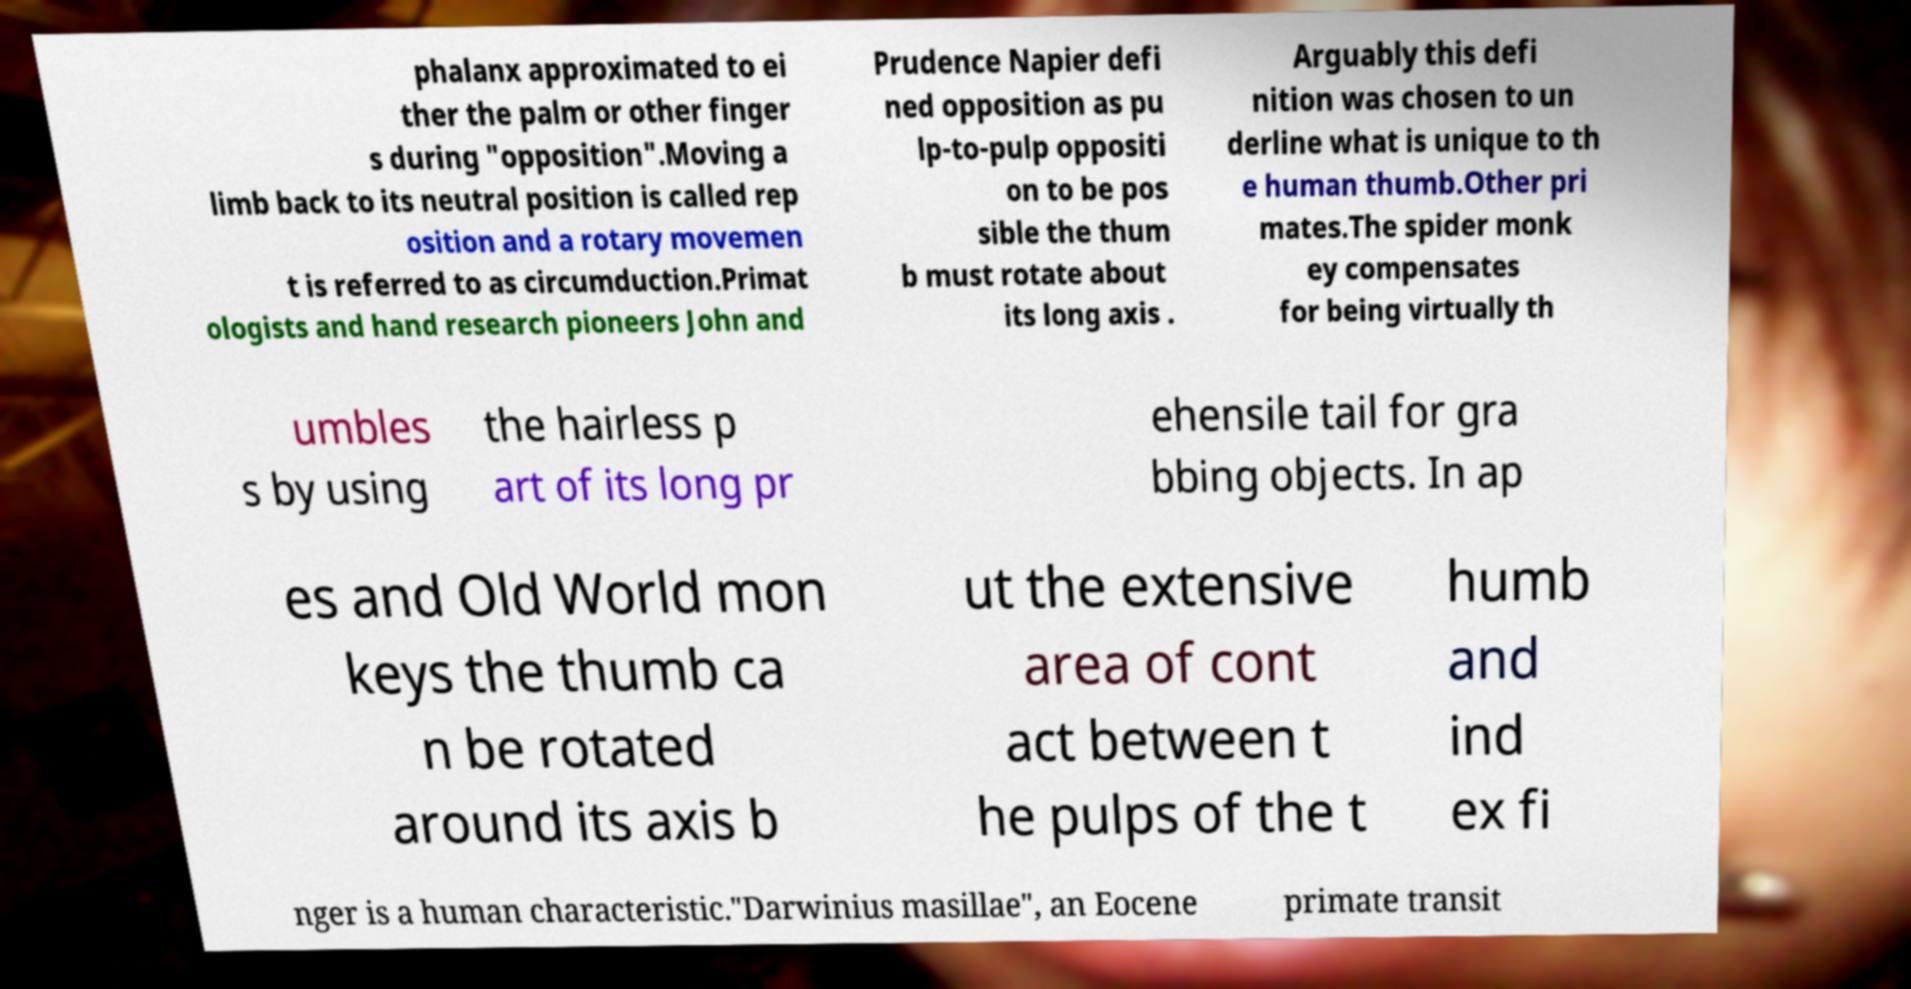Please identify and transcribe the text found in this image. phalanx approximated to ei ther the palm or other finger s during "opposition".Moving a limb back to its neutral position is called rep osition and a rotary movemen t is referred to as circumduction.Primat ologists and hand research pioneers John and Prudence Napier defi ned opposition as pu lp-to-pulp oppositi on to be pos sible the thum b must rotate about its long axis . Arguably this defi nition was chosen to un derline what is unique to th e human thumb.Other pri mates.The spider monk ey compensates for being virtually th umbles s by using the hairless p art of its long pr ehensile tail for gra bbing objects. In ap es and Old World mon keys the thumb ca n be rotated around its axis b ut the extensive area of cont act between t he pulps of the t humb and ind ex fi nger is a human characteristic."Darwinius masillae", an Eocene primate transit 